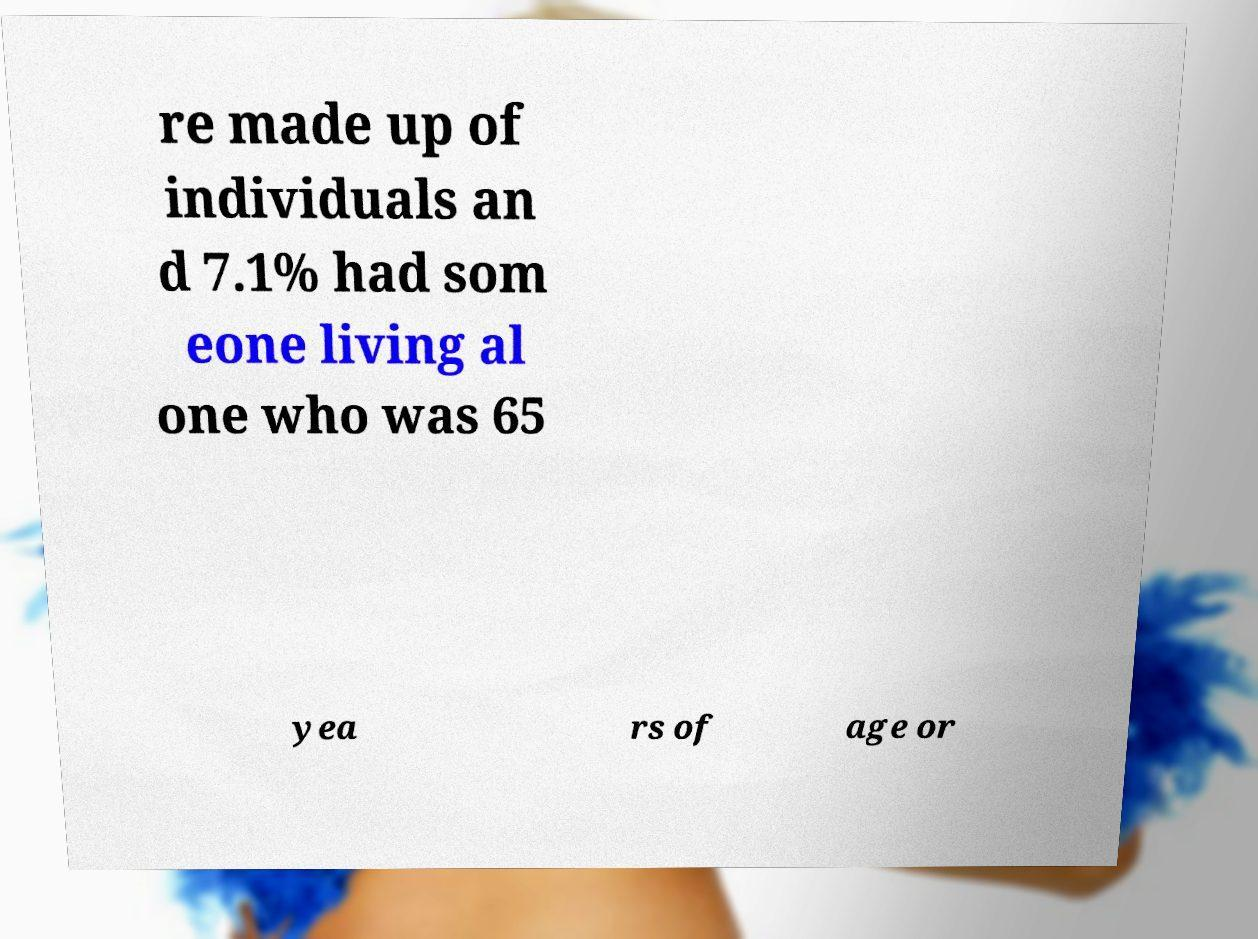There's text embedded in this image that I need extracted. Can you transcribe it verbatim? re made up of individuals an d 7.1% had som eone living al one who was 65 yea rs of age or 